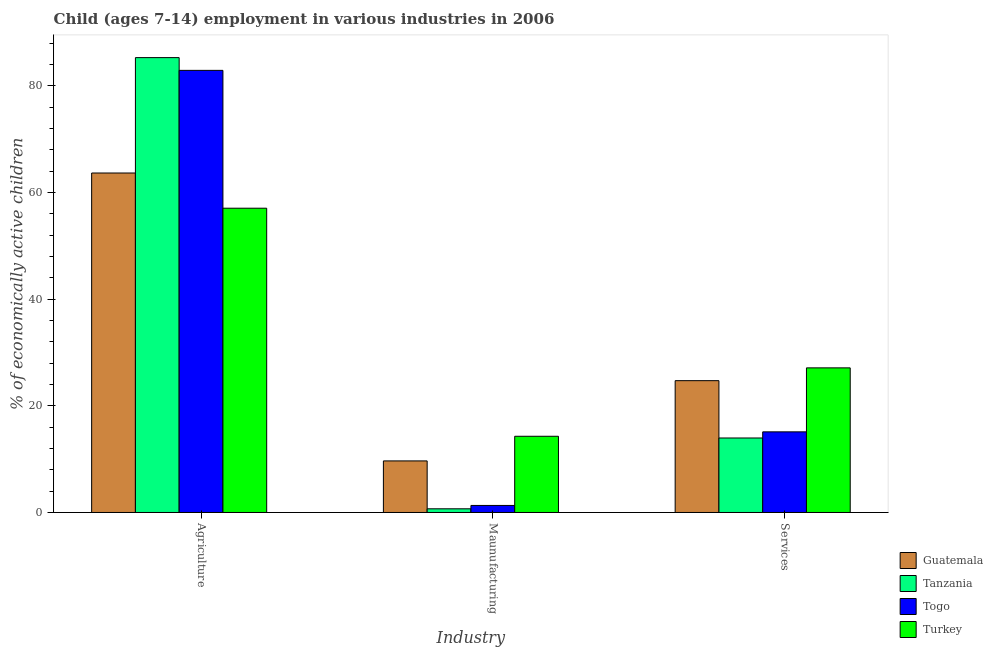How many different coloured bars are there?
Provide a succinct answer. 4. How many groups of bars are there?
Provide a short and direct response. 3. Are the number of bars per tick equal to the number of legend labels?
Give a very brief answer. Yes. How many bars are there on the 2nd tick from the right?
Give a very brief answer. 4. What is the label of the 1st group of bars from the left?
Offer a terse response. Agriculture. What is the percentage of economically active children in services in Tanzania?
Give a very brief answer. 13.97. Across all countries, what is the maximum percentage of economically active children in manufacturing?
Offer a very short reply. 14.29. Across all countries, what is the minimum percentage of economically active children in agriculture?
Make the answer very short. 57.06. In which country was the percentage of economically active children in agriculture maximum?
Offer a very short reply. Tanzania. What is the total percentage of economically active children in manufacturing in the graph?
Give a very brief answer. 25.97. What is the difference between the percentage of economically active children in services in Togo and that in Turkey?
Provide a succinct answer. -12. What is the difference between the percentage of economically active children in agriculture in Turkey and the percentage of economically active children in manufacturing in Togo?
Your answer should be compact. 55.74. What is the average percentage of economically active children in manufacturing per country?
Your answer should be very brief. 6.49. What is the difference between the percentage of economically active children in services and percentage of economically active children in manufacturing in Togo?
Ensure brevity in your answer.  13.8. What is the ratio of the percentage of economically active children in manufacturing in Turkey to that in Guatemala?
Your response must be concise. 1.48. Is the percentage of economically active children in manufacturing in Tanzania less than that in Guatemala?
Provide a succinct answer. Yes. Is the difference between the percentage of economically active children in services in Tanzania and Guatemala greater than the difference between the percentage of economically active children in agriculture in Tanzania and Guatemala?
Provide a succinct answer. No. What is the difference between the highest and the second highest percentage of economically active children in services?
Offer a very short reply. 2.4. What is the difference between the highest and the lowest percentage of economically active children in agriculture?
Ensure brevity in your answer.  28.24. Is the sum of the percentage of economically active children in manufacturing in Guatemala and Togo greater than the maximum percentage of economically active children in agriculture across all countries?
Keep it short and to the point. No. What does the 1st bar from the left in Services represents?
Ensure brevity in your answer.  Guatemala. What does the 2nd bar from the right in Services represents?
Your answer should be very brief. Togo. How many bars are there?
Offer a terse response. 12. Are all the bars in the graph horizontal?
Offer a very short reply. No. Where does the legend appear in the graph?
Offer a very short reply. Bottom right. How are the legend labels stacked?
Ensure brevity in your answer.  Vertical. What is the title of the graph?
Your answer should be very brief. Child (ages 7-14) employment in various industries in 2006. Does "Cambodia" appear as one of the legend labels in the graph?
Give a very brief answer. No. What is the label or title of the X-axis?
Offer a terse response. Industry. What is the label or title of the Y-axis?
Provide a short and direct response. % of economically active children. What is the % of economically active children in Guatemala in Agriculture?
Your answer should be compact. 63.66. What is the % of economically active children of Tanzania in Agriculture?
Keep it short and to the point. 85.3. What is the % of economically active children in Togo in Agriculture?
Ensure brevity in your answer.  82.91. What is the % of economically active children of Turkey in Agriculture?
Provide a short and direct response. 57.06. What is the % of economically active children of Guatemala in Maunufacturing?
Give a very brief answer. 9.67. What is the % of economically active children of Tanzania in Maunufacturing?
Give a very brief answer. 0.69. What is the % of economically active children of Togo in Maunufacturing?
Provide a short and direct response. 1.32. What is the % of economically active children of Turkey in Maunufacturing?
Offer a very short reply. 14.29. What is the % of economically active children of Guatemala in Services?
Ensure brevity in your answer.  24.72. What is the % of economically active children of Tanzania in Services?
Give a very brief answer. 13.97. What is the % of economically active children of Togo in Services?
Offer a terse response. 15.12. What is the % of economically active children of Turkey in Services?
Keep it short and to the point. 27.12. Across all Industry, what is the maximum % of economically active children of Guatemala?
Your answer should be very brief. 63.66. Across all Industry, what is the maximum % of economically active children of Tanzania?
Keep it short and to the point. 85.3. Across all Industry, what is the maximum % of economically active children in Togo?
Offer a terse response. 82.91. Across all Industry, what is the maximum % of economically active children of Turkey?
Your answer should be compact. 57.06. Across all Industry, what is the minimum % of economically active children of Guatemala?
Offer a terse response. 9.67. Across all Industry, what is the minimum % of economically active children of Tanzania?
Provide a short and direct response. 0.69. Across all Industry, what is the minimum % of economically active children in Togo?
Ensure brevity in your answer.  1.32. Across all Industry, what is the minimum % of economically active children of Turkey?
Your answer should be very brief. 14.29. What is the total % of economically active children of Guatemala in the graph?
Make the answer very short. 98.05. What is the total % of economically active children in Tanzania in the graph?
Offer a terse response. 99.96. What is the total % of economically active children of Togo in the graph?
Offer a very short reply. 99.35. What is the total % of economically active children of Turkey in the graph?
Provide a short and direct response. 98.47. What is the difference between the % of economically active children in Guatemala in Agriculture and that in Maunufacturing?
Your answer should be very brief. 53.99. What is the difference between the % of economically active children in Tanzania in Agriculture and that in Maunufacturing?
Offer a very short reply. 84.61. What is the difference between the % of economically active children in Togo in Agriculture and that in Maunufacturing?
Make the answer very short. 81.59. What is the difference between the % of economically active children in Turkey in Agriculture and that in Maunufacturing?
Provide a short and direct response. 42.77. What is the difference between the % of economically active children of Guatemala in Agriculture and that in Services?
Give a very brief answer. 38.94. What is the difference between the % of economically active children in Tanzania in Agriculture and that in Services?
Give a very brief answer. 71.33. What is the difference between the % of economically active children of Togo in Agriculture and that in Services?
Give a very brief answer. 67.79. What is the difference between the % of economically active children in Turkey in Agriculture and that in Services?
Provide a succinct answer. 29.94. What is the difference between the % of economically active children of Guatemala in Maunufacturing and that in Services?
Offer a terse response. -15.05. What is the difference between the % of economically active children of Tanzania in Maunufacturing and that in Services?
Ensure brevity in your answer.  -13.28. What is the difference between the % of economically active children of Turkey in Maunufacturing and that in Services?
Ensure brevity in your answer.  -12.83. What is the difference between the % of economically active children in Guatemala in Agriculture and the % of economically active children in Tanzania in Maunufacturing?
Keep it short and to the point. 62.97. What is the difference between the % of economically active children in Guatemala in Agriculture and the % of economically active children in Togo in Maunufacturing?
Your response must be concise. 62.34. What is the difference between the % of economically active children in Guatemala in Agriculture and the % of economically active children in Turkey in Maunufacturing?
Your response must be concise. 49.37. What is the difference between the % of economically active children of Tanzania in Agriculture and the % of economically active children of Togo in Maunufacturing?
Your answer should be very brief. 83.98. What is the difference between the % of economically active children in Tanzania in Agriculture and the % of economically active children in Turkey in Maunufacturing?
Ensure brevity in your answer.  71.01. What is the difference between the % of economically active children of Togo in Agriculture and the % of economically active children of Turkey in Maunufacturing?
Provide a short and direct response. 68.62. What is the difference between the % of economically active children in Guatemala in Agriculture and the % of economically active children in Tanzania in Services?
Your answer should be very brief. 49.69. What is the difference between the % of economically active children in Guatemala in Agriculture and the % of economically active children in Togo in Services?
Your response must be concise. 48.54. What is the difference between the % of economically active children of Guatemala in Agriculture and the % of economically active children of Turkey in Services?
Offer a terse response. 36.54. What is the difference between the % of economically active children of Tanzania in Agriculture and the % of economically active children of Togo in Services?
Provide a succinct answer. 70.18. What is the difference between the % of economically active children in Tanzania in Agriculture and the % of economically active children in Turkey in Services?
Provide a succinct answer. 58.18. What is the difference between the % of economically active children in Togo in Agriculture and the % of economically active children in Turkey in Services?
Make the answer very short. 55.79. What is the difference between the % of economically active children of Guatemala in Maunufacturing and the % of economically active children of Togo in Services?
Offer a very short reply. -5.45. What is the difference between the % of economically active children in Guatemala in Maunufacturing and the % of economically active children in Turkey in Services?
Give a very brief answer. -17.45. What is the difference between the % of economically active children in Tanzania in Maunufacturing and the % of economically active children in Togo in Services?
Offer a terse response. -14.43. What is the difference between the % of economically active children of Tanzania in Maunufacturing and the % of economically active children of Turkey in Services?
Make the answer very short. -26.43. What is the difference between the % of economically active children in Togo in Maunufacturing and the % of economically active children in Turkey in Services?
Your answer should be very brief. -25.8. What is the average % of economically active children of Guatemala per Industry?
Offer a terse response. 32.68. What is the average % of economically active children of Tanzania per Industry?
Keep it short and to the point. 33.32. What is the average % of economically active children in Togo per Industry?
Provide a succinct answer. 33.12. What is the average % of economically active children of Turkey per Industry?
Offer a terse response. 32.82. What is the difference between the % of economically active children in Guatemala and % of economically active children in Tanzania in Agriculture?
Your answer should be very brief. -21.64. What is the difference between the % of economically active children of Guatemala and % of economically active children of Togo in Agriculture?
Provide a short and direct response. -19.25. What is the difference between the % of economically active children of Guatemala and % of economically active children of Turkey in Agriculture?
Your answer should be compact. 6.6. What is the difference between the % of economically active children of Tanzania and % of economically active children of Togo in Agriculture?
Your answer should be compact. 2.39. What is the difference between the % of economically active children in Tanzania and % of economically active children in Turkey in Agriculture?
Offer a very short reply. 28.24. What is the difference between the % of economically active children in Togo and % of economically active children in Turkey in Agriculture?
Your answer should be compact. 25.85. What is the difference between the % of economically active children in Guatemala and % of economically active children in Tanzania in Maunufacturing?
Ensure brevity in your answer.  8.98. What is the difference between the % of economically active children in Guatemala and % of economically active children in Togo in Maunufacturing?
Your answer should be very brief. 8.35. What is the difference between the % of economically active children of Guatemala and % of economically active children of Turkey in Maunufacturing?
Offer a very short reply. -4.62. What is the difference between the % of economically active children of Tanzania and % of economically active children of Togo in Maunufacturing?
Give a very brief answer. -0.63. What is the difference between the % of economically active children of Togo and % of economically active children of Turkey in Maunufacturing?
Ensure brevity in your answer.  -12.97. What is the difference between the % of economically active children of Guatemala and % of economically active children of Tanzania in Services?
Offer a very short reply. 10.75. What is the difference between the % of economically active children in Tanzania and % of economically active children in Togo in Services?
Offer a terse response. -1.15. What is the difference between the % of economically active children of Tanzania and % of economically active children of Turkey in Services?
Provide a succinct answer. -13.15. What is the ratio of the % of economically active children in Guatemala in Agriculture to that in Maunufacturing?
Offer a terse response. 6.58. What is the ratio of the % of economically active children in Tanzania in Agriculture to that in Maunufacturing?
Provide a short and direct response. 123.62. What is the ratio of the % of economically active children in Togo in Agriculture to that in Maunufacturing?
Keep it short and to the point. 62.81. What is the ratio of the % of economically active children of Turkey in Agriculture to that in Maunufacturing?
Your response must be concise. 3.99. What is the ratio of the % of economically active children of Guatemala in Agriculture to that in Services?
Provide a succinct answer. 2.58. What is the ratio of the % of economically active children in Tanzania in Agriculture to that in Services?
Provide a short and direct response. 6.11. What is the ratio of the % of economically active children in Togo in Agriculture to that in Services?
Offer a very short reply. 5.48. What is the ratio of the % of economically active children of Turkey in Agriculture to that in Services?
Give a very brief answer. 2.1. What is the ratio of the % of economically active children in Guatemala in Maunufacturing to that in Services?
Offer a terse response. 0.39. What is the ratio of the % of economically active children in Tanzania in Maunufacturing to that in Services?
Ensure brevity in your answer.  0.05. What is the ratio of the % of economically active children of Togo in Maunufacturing to that in Services?
Ensure brevity in your answer.  0.09. What is the ratio of the % of economically active children in Turkey in Maunufacturing to that in Services?
Offer a terse response. 0.53. What is the difference between the highest and the second highest % of economically active children of Guatemala?
Provide a succinct answer. 38.94. What is the difference between the highest and the second highest % of economically active children in Tanzania?
Your answer should be very brief. 71.33. What is the difference between the highest and the second highest % of economically active children in Togo?
Make the answer very short. 67.79. What is the difference between the highest and the second highest % of economically active children of Turkey?
Your response must be concise. 29.94. What is the difference between the highest and the lowest % of economically active children in Guatemala?
Your answer should be compact. 53.99. What is the difference between the highest and the lowest % of economically active children in Tanzania?
Keep it short and to the point. 84.61. What is the difference between the highest and the lowest % of economically active children of Togo?
Your answer should be very brief. 81.59. What is the difference between the highest and the lowest % of economically active children in Turkey?
Provide a succinct answer. 42.77. 